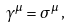Convert formula to latex. <formula><loc_0><loc_0><loc_500><loc_500>\gamma ^ { \mu } = \sigma ^ { \mu } \, ,</formula> 